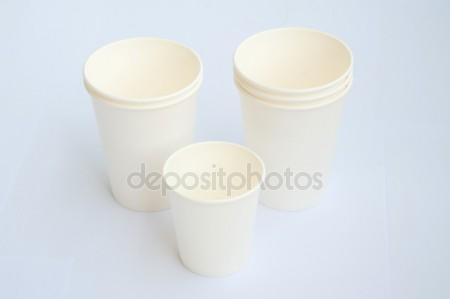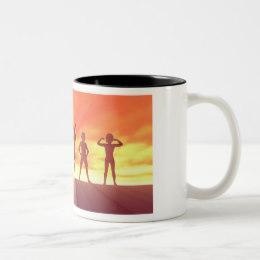The first image is the image on the left, the second image is the image on the right. Examine the images to the left and right. Is the description "There are more cups in the left image than in the right image." accurate? Answer yes or no. Yes. The first image is the image on the left, the second image is the image on the right. Assess this claim about the two images: "Some of the cups are stacked one on top of another". Correct or not? Answer yes or no. Yes. 